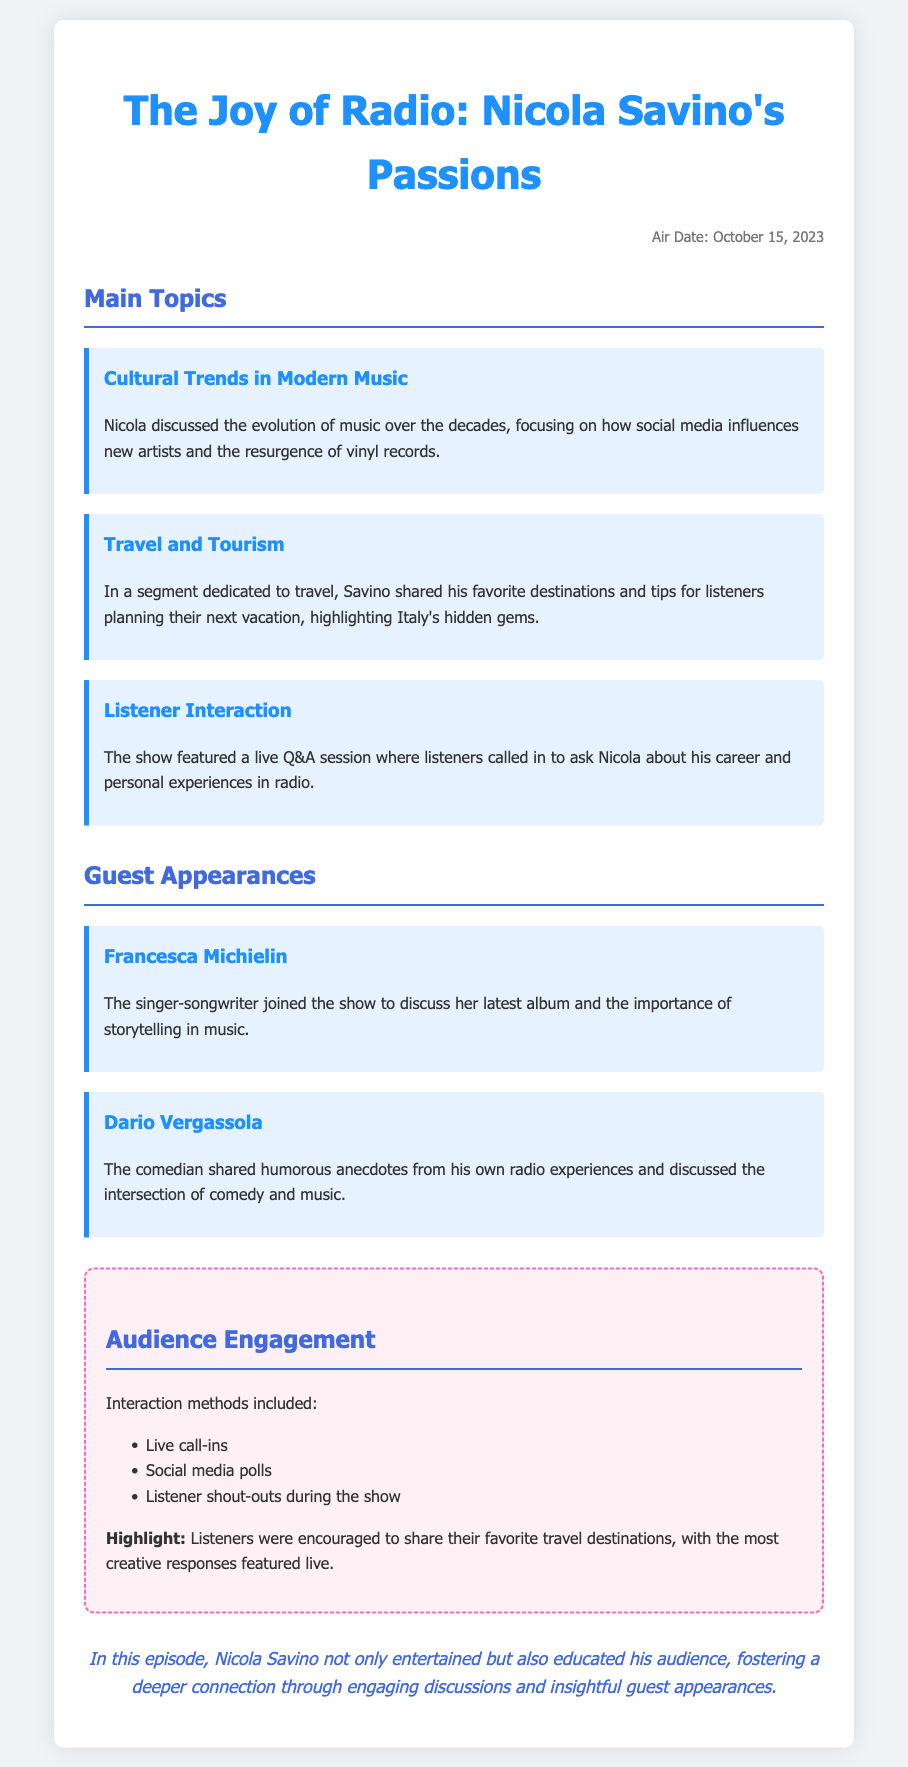What is the air date of the show? The air date is mentioned at the beginning of the document.
Answer: October 15, 2023 Who is a guest that discussed storytelling in music? The document lists guest Francesca Michielin as discussing her latest album and storytelling.
Answer: Francesca Michielin What was one of the main topics discussed in the show? The document highlights several main topics, including cultural trends in music.
Answer: Cultural Trends in Modern Music What method was used for audience engagement? The document describes various methods used for audience engagement, including live call-ins.
Answer: Live call-ins What genre does Dario Vergassola work in? The document states that Dario Vergassola is a comedian, indicating his genre.
Answer: Comedy How did listeners share their favorite travel destinations? The document specifies that listeners were encouraged to share their favorite travel destinations during the show.
Answer: Live Which destination type did Nicola Savino highlight in his travel segment? The document mentions that Nicola highlighted Italy's hidden gems.
Answer: Italy's hidden gems What was the focus of Nicola’s discussion on music? The document outlines that Nicola focused on how social media influences new artists.
Answer: Social media influences What type of session was featured in the show for listeners? The document specifies that there was a live Q&A session for listener interaction.
Answer: Live Q&A session 